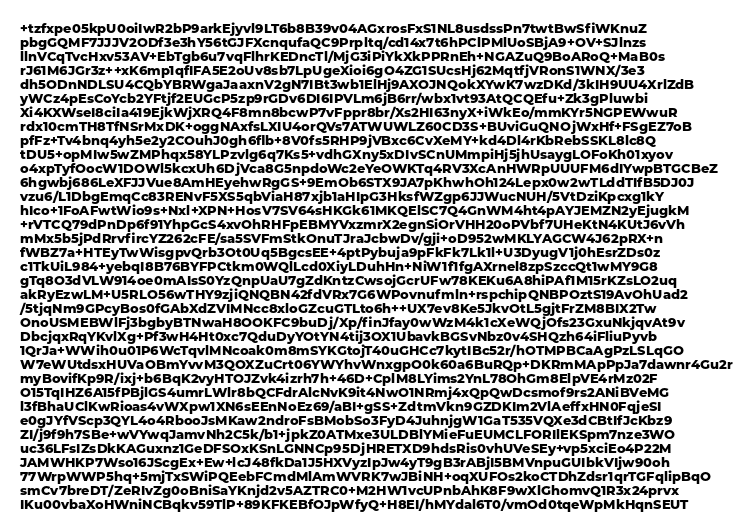<code> <loc_0><loc_0><loc_500><loc_500><_PHP_>+tzfxpe05kpU0oiIwR2bP9arkEjyvl9LT6b8B39v04AGxrosFxS1NL8usdssPn7twtBwSfiWKnuZ
pbgGQMF7JJJV2ODf3e3hY56tGJFXcnqufaQC9Prpltq/cd14x7t6hPClPMlUoSBjA9+OV+SJlnzs
llnVCqTvcHxv53AV+EbTgb6u7vqFlhrKEDncTl/MjG3iPiYkXkPPRnEh+NGAZuQ9BoARoQ+MaB0s
rJ61M6JGr3z++xK6mp1qfIFA5E2oUv8sb7LpUgeXioi6gO4ZG1SUcsHj62MqtfjVRonS1WNX/3e3
dh5ODnNDLSU4CQbYBRWgaJaaxnV2gN7IBt3wb1ElHj9AXOJNQokXYwK7wzDKd/3kIH9UU4XrlZdB
yWCz4pEsCoYcb2YFtjf2EUGcP5zp9rGDv6DI6IPVLm6jB6rr/wbx1vt93AtQCQEfu+Zk3gPluwbi
Xi4KXWseI8ciIa419EjkWjXRQ4F8mn8bcwP7vFppr8br/Xs2HI63nyX+iWkEo/mmKYr5NGPEWwuR
rdx10cmTH8TfNSrMxDK+oggNAxfsLXIU4orQVs7ATWUWLZ60CD3S+BUviGuQNOjWxHf+FSgEZ7oB
pfFz+Tv4bnq4yh5e2y2COuhJ0gh6flb+8V0fs5RHP9jVBxc6CvXeMY+kd4Dl4rKbRebSSKL8lc8Q
tDU5+opMIw5wZMPhqx58YLPzvlg6q7Ks5+vdhGXny5xDIvSCnUMmpiHj5jhUsaygLOFoKh01xyov
o4xpTyfOocW1DOWl5kcxUh6DjVca8G5npdoWc2eYeOWKTq4RV3XcAnHWRpUUUFM6dIYwpBTGCBeZ
6hgwbj686LeXFJJVue8AmHEyehwRgGS+9EmOb6STX9JA7pKhwhOh124Lepx0w2wTLddTIfB5DJ0J
vzu6/L1DbgEmqCc83RENvF5XS5qbViaH87xjb1aHIpG3HksfWZgp6JJWucNUH/5VtDziKpcxg1kY
hIco+1FoAFwtWio9s+Nxl+XPN+HosV7SV64sHKGk61MKQElSC7Q4GnWM4ht4pAYJEMZN2yEjugkM
+rVTCQ79dPnDp6f91YhpGcS4xvOhRHFpEBMYVxzmrX2egnSiOrVHH20oPVbf7UHeKtN4KUtJ6vVh
mMx5b5jPdRrvfircYZ262cFE/sa5SVFmStkOnuTJraJcbwDv/gji+oD952wMKLYAGCW4J62pRX+n
fWBZ7a+HTEyTwWisgpvQrb3Ot0Uq5BgcsEE+4ptPybuja9pFkFk7Lk1l+U3DyugV1j0hEsrZDs0z
c1TkUiL984+yebqI8B76BYFPCtkm0WQlLcd0XiyLDuhHn+NiW1f1fgAXrnel8zpSzccQt1wMY9G8
gTq8O3dVLW914oe0mAIsS0YzQnpUaU7gZdKntzCwsojGcrUFw78KEKu6A8hiPAf1M15rKZsLO2uq
akRyEzwLM+U5RLO56wTHY9zjiQNQBN42fdVRx7G6WPovnufmln+rspchipQNBPOztS19AvOhUad2
/5tjqNm9GPcyBos0fGAbXdZVIMNcc8xloGZcuGTLto6h++UX7ev8Ke5JkvOtL5gjtFrZM8BIX2Tw
OnoUSMEBWlFj3bgbyBTNwaH8OOKFC9buDj/Xp/finJfay0wWzM4k1cXeWQjOfs23GxuNkjqvAt9v
DbcjqxRqYKvlXg+Pf3wH4Ht0xc7QduDyYOtYN4tij3OX1UbavkBGSvNbz0v4SHQzh64iFliuPyvb
1QrJa+WWih0u01P6WcTqvlMNcoak0m8mSYKGtojT40uGHCc7kytIBc52r/hOTMPBCaAgPzLSLqGO
W7eWUtdsxHUVaOBmYvvM3QOXZuCrt06YWYhvWnxgpO0k60a6BuRQp+DKRmMApPpJa7dawnr4Gu2r
myBovifKp9R/ixj+b6BqK2vyHTOJZvk4izrh7h+46D+CplM8LYims2YnL78OhGm8ElpVE4rMz02F
O15TqIHZ6A15fPBjlGS4umrLWlr8bQCFdrAlcNvK9it4NwO1NRmj4xQpQwDcsmof9rs2ANiBVeMG
l3fBhaUClKwRioas4vWXpw1XN6sEEnNoEz69/aBI+gSS+ZdtmVkn9GZDKIm2VlAeffxHN0FqjeSI
e0gJYfVScp3QYL4o4RbooJsMKaw2ndroFsBMobSo3FyD4JuhnjgW1GaT535VQXe3dCBtIfJcKbz9
ZI/j9f9h7SBe+wVYwqJamvNh2C5k/b1+jpkZ0ATMxe3ULDBlYMieFuEUMCLFORIlEKSpm7nze3WO
uc36LFsIZsDkKAGuxnz1GeDFSOxKSnLGNNCp95DjHRETXD9hdsRis0vhUVeSEy+vp5xciEo4P22M
JAMWHKP7Wso16JScgEx+Ew+lcJ48fkDa1J5HXVyzIpJw4yT9gB3rABjI5BMVnpuGUIbkVIjw90oh
77WrpWWP5hq+5mjTxSWiPQEebFCmdMlAmWVRK7wJBiNH+oqXUFOs2koCTDhZdsr1qrTGFqlipBqO
smCv7breDT/ZeRIvZg0oBniSaYKnjd2v5AZTRC0+M2HW1vcUPnbAhK8F9wXlGhomvQ1R3x24prvx
IKu00vbaXoHWniNCBqkv59TlP+89KFKEBfOJpWfyQ+H8EI/hMYdal6T0/vmOd0tqeWpMkHqnSEUT</code> 